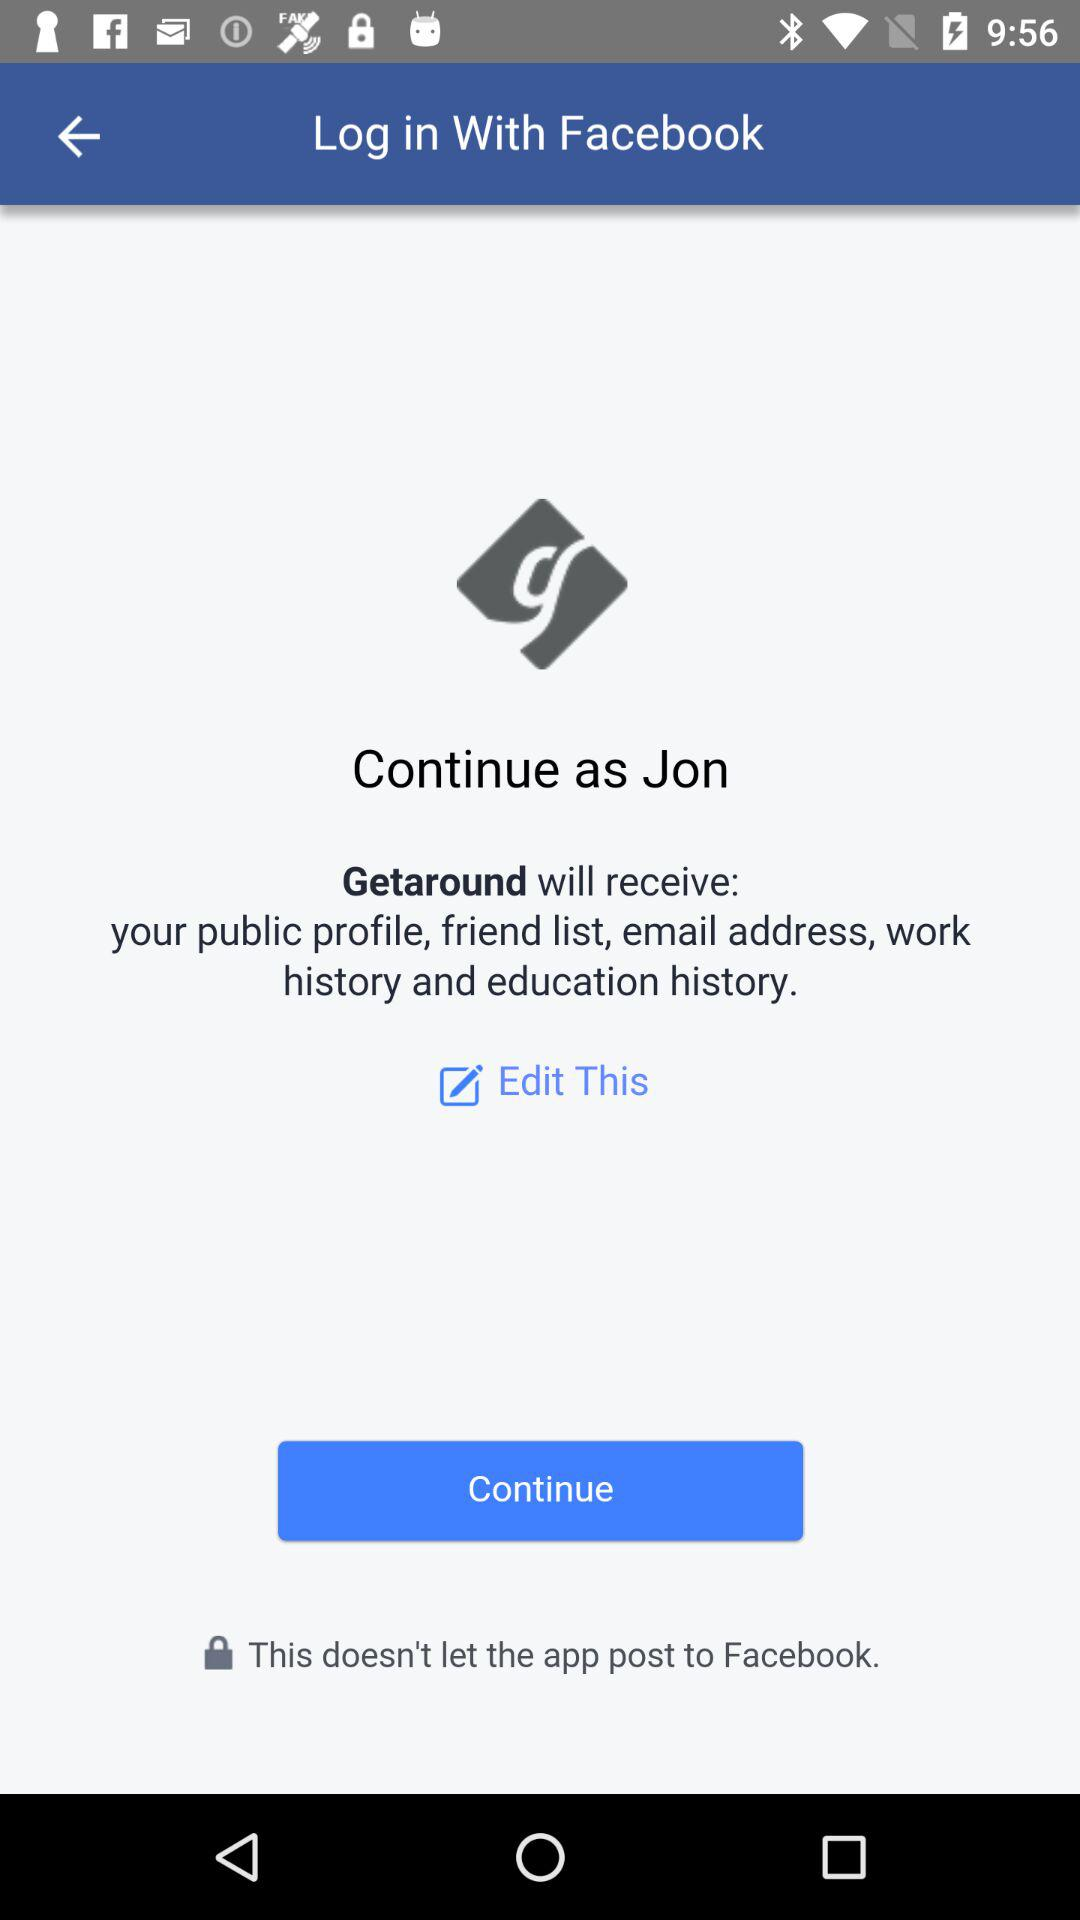Through what application can we log in? You can log in through "Facebook". 